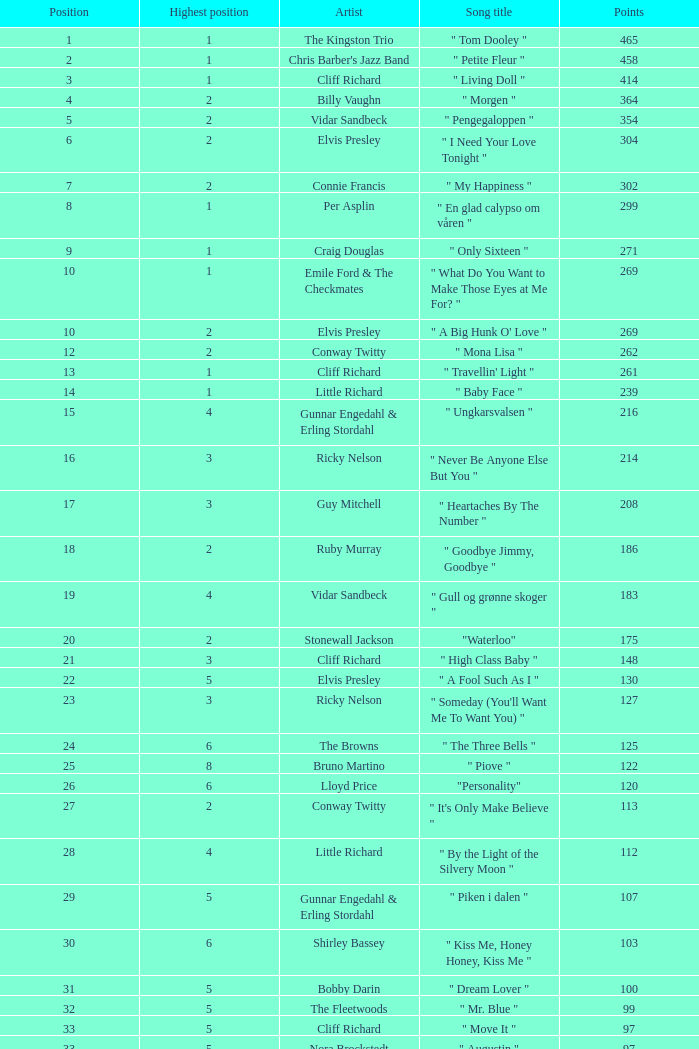Could you help me parse every detail presented in this table? {'header': ['Position', 'Highest position', 'Artist', 'Song title', 'Points'], 'rows': [['1', '1', 'The Kingston Trio', '" Tom Dooley "', '465'], ['2', '1', "Chris Barber's Jazz Band", '" Petite Fleur "', '458'], ['3', '1', 'Cliff Richard', '" Living Doll "', '414'], ['4', '2', 'Billy Vaughn', '" Morgen "', '364'], ['5', '2', 'Vidar Sandbeck', '" Pengegaloppen "', '354'], ['6', '2', 'Elvis Presley', '" I Need Your Love Tonight "', '304'], ['7', '2', 'Connie Francis', '" My Happiness "', '302'], ['8', '1', 'Per Asplin', '" En glad calypso om våren "', '299'], ['9', '1', 'Craig Douglas', '" Only Sixteen "', '271'], ['10', '1', 'Emile Ford & The Checkmates', '" What Do You Want to Make Those Eyes at Me For? "', '269'], ['10', '2', 'Elvis Presley', '" A Big Hunk O\' Love "', '269'], ['12', '2', 'Conway Twitty', '" Mona Lisa "', '262'], ['13', '1', 'Cliff Richard', '" Travellin\' Light "', '261'], ['14', '1', 'Little Richard', '" Baby Face "', '239'], ['15', '4', 'Gunnar Engedahl & Erling Stordahl', '" Ungkarsvalsen "', '216'], ['16', '3', 'Ricky Nelson', '" Never Be Anyone Else But You "', '214'], ['17', '3', 'Guy Mitchell', '" Heartaches By The Number "', '208'], ['18', '2', 'Ruby Murray', '" Goodbye Jimmy, Goodbye "', '186'], ['19', '4', 'Vidar Sandbeck', '" Gull og grønne skoger "', '183'], ['20', '2', 'Stonewall Jackson', '"Waterloo"', '175'], ['21', '3', 'Cliff Richard', '" High Class Baby "', '148'], ['22', '5', 'Elvis Presley', '" A Fool Such As I "', '130'], ['23', '3', 'Ricky Nelson', '" Someday (You\'ll Want Me To Want You) "', '127'], ['24', '6', 'The Browns', '" The Three Bells "', '125'], ['25', '8', 'Bruno Martino', '" Piove "', '122'], ['26', '6', 'Lloyd Price', '"Personality"', '120'], ['27', '2', 'Conway Twitty', '" It\'s Only Make Believe "', '113'], ['28', '4', 'Little Richard', '" By the Light of the Silvery Moon "', '112'], ['29', '5', 'Gunnar Engedahl & Erling Stordahl', '" Piken i dalen "', '107'], ['30', '6', 'Shirley Bassey', '" Kiss Me, Honey Honey, Kiss Me "', '103'], ['31', '5', 'Bobby Darin', '" Dream Lover "', '100'], ['32', '5', 'The Fleetwoods', '" Mr. Blue "', '99'], ['33', '5', 'Cliff Richard', '" Move It "', '97'], ['33', '5', 'Nora Brockstedt', '" Augustin "', '97'], ['35', '5', 'The Coasters', '" Charlie Brown "', '85'], ['36', '5', 'Cliff Richard', '" Never Mind "', '82'], ['37', '8', 'Jerry Keller', '" Here Comes Summer "', '73'], ['38', '7', 'Connie Francis', '" Lipstick On Your Collar "', '80'], ['39', '8', 'Lloyd Price', '" Stagger Lee "', '58'], ['40', '7', 'Floyd Robinson', '" Makin\' Love "', '53'], ['41', '7', 'Jane Morgan', '" The Day The Rains Came "', '49'], ['42', '6', 'Bing Crosby', '" White Christmas "', '41'], ['43', '9', 'Paul Anka', '" Lonely Boy "', '36'], ['44', '9', 'Bobby Darin', '" Mack The Knife "', '34'], ['45', '9', 'Pat Boone', '" I\'ll Remember Tonight "', '23'], ['46', '10', 'Sam Cooke', '" Only Sixteen "', '22'], ['47', '9', 'Bruno Martino', '" Come prima "', '12']]} What is the nme of the song performed by billy vaughn? " Morgen ". 